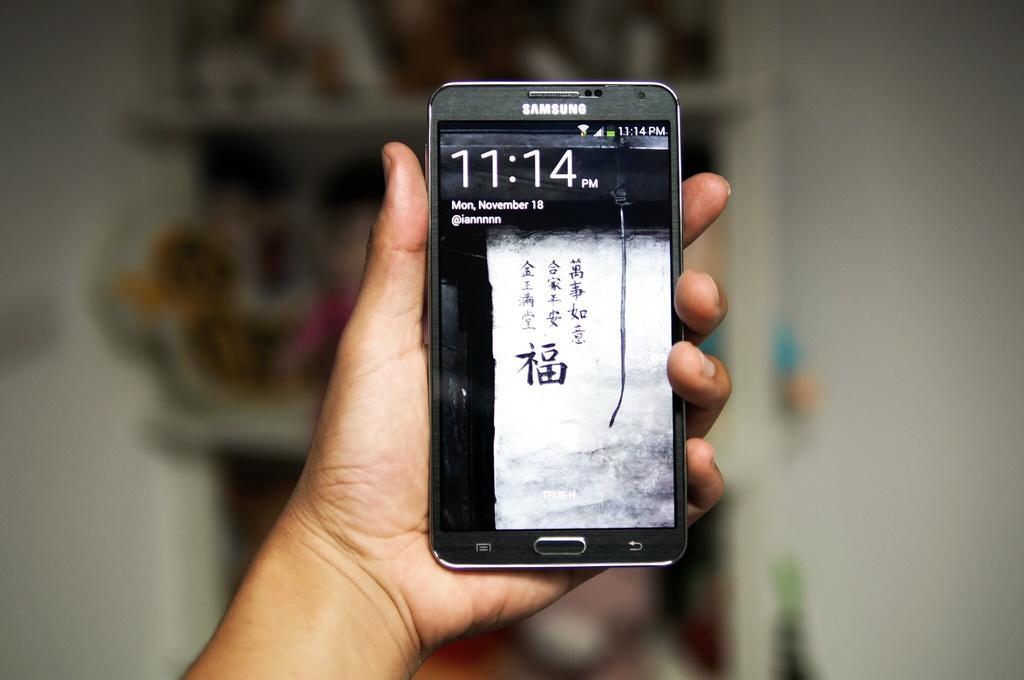Can you describe this image briefly? In the center of the image we can see a person is holding a mobile. In the background of the image we can see a rack and some objects, wall. 